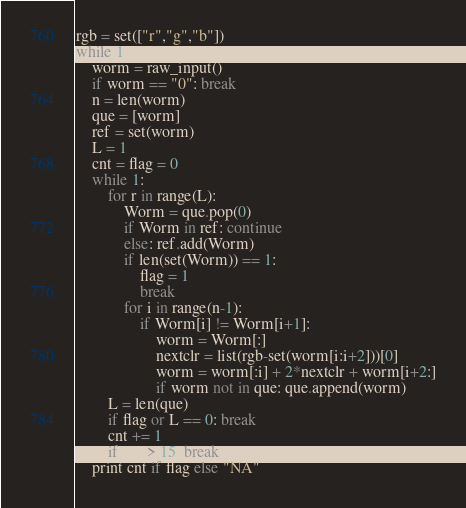<code> <loc_0><loc_0><loc_500><loc_500><_Python_>rgb = set(["r","g","b"])
while 1:
	worm = raw_input()
	if worm == "0": break
	n = len(worm)
	que = [worm]
	ref = set(worm)
	L = 1
	cnt = flag = 0
	while 1:
		for r in range(L):
			Worm = que.pop(0)
			if Worm in ref: continue
			else: ref.add(Worm)
			if len(set(Worm)) == 1:
				flag = 1
				break
			for i in range(n-1):
				if Worm[i] != Worm[i+1]:
					worm = Worm[:]
					nextclr = list(rgb-set(worm[i:i+2]))[0]
					worm = worm[:i] + 2*nextclr + worm[i+2:]
					if worm not in que: que.append(worm)
		L = len(que)
		if flag or L == 0: break
		cnt += 1
		if cnt > 15: break
	print cnt if flag else "NA"</code> 